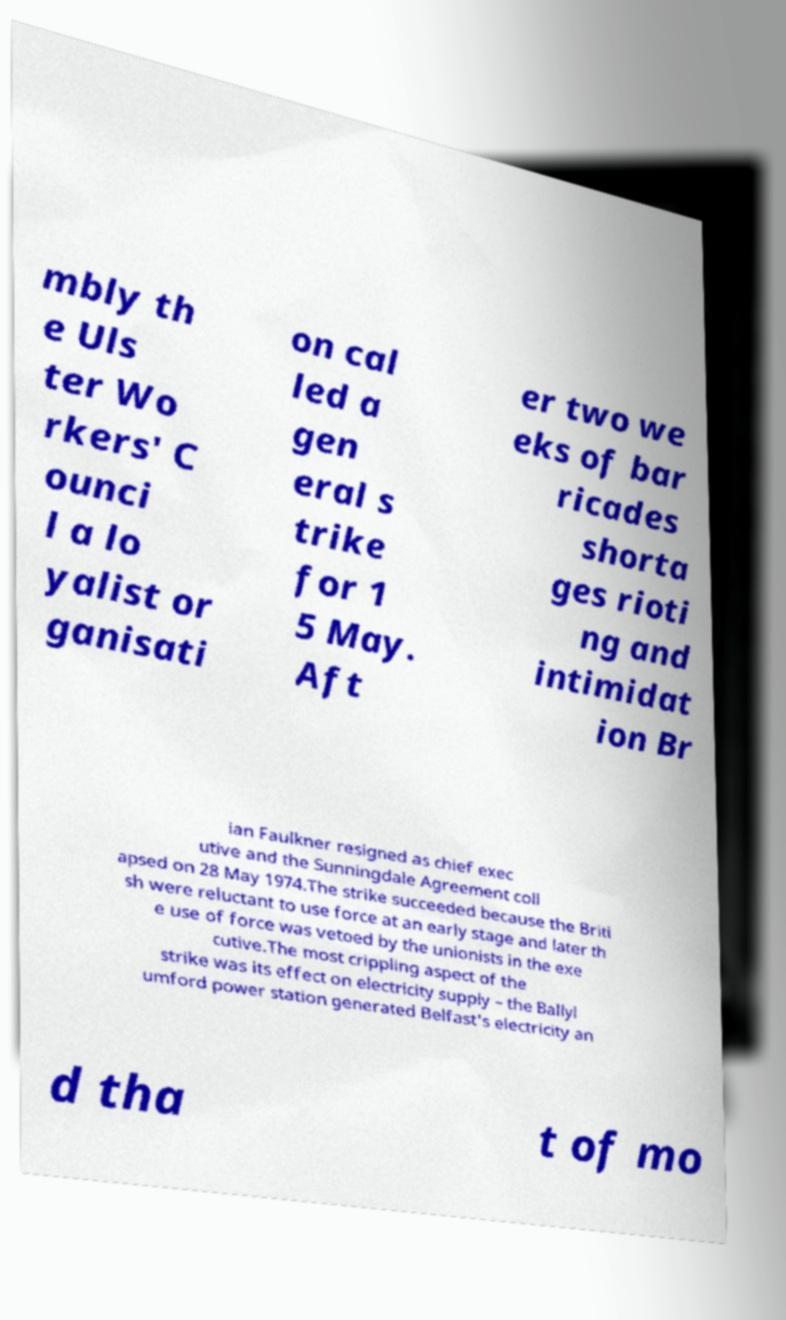Please read and relay the text visible in this image. What does it say? mbly th e Uls ter Wo rkers' C ounci l a lo yalist or ganisati on cal led a gen eral s trike for 1 5 May. Aft er two we eks of bar ricades shorta ges rioti ng and intimidat ion Br ian Faulkner resigned as chief exec utive and the Sunningdale Agreement coll apsed on 28 May 1974.The strike succeeded because the Briti sh were reluctant to use force at an early stage and later th e use of force was vetoed by the unionists in the exe cutive.The most crippling aspect of the strike was its effect on electricity supply – the Ballyl umford power station generated Belfast's electricity an d tha t of mo 